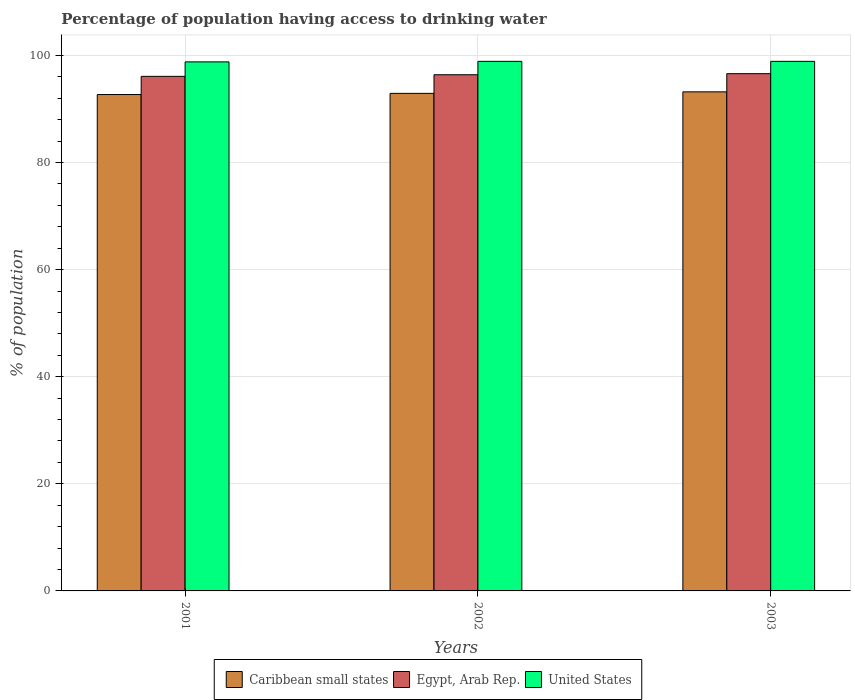How many different coloured bars are there?
Your response must be concise. 3. How many groups of bars are there?
Provide a short and direct response. 3. In how many cases, is the number of bars for a given year not equal to the number of legend labels?
Your answer should be very brief. 0. What is the percentage of population having access to drinking water in Caribbean small states in 2001?
Provide a succinct answer. 92.7. Across all years, what is the maximum percentage of population having access to drinking water in Egypt, Arab Rep.?
Keep it short and to the point. 96.6. Across all years, what is the minimum percentage of population having access to drinking water in Caribbean small states?
Ensure brevity in your answer.  92.7. What is the total percentage of population having access to drinking water in United States in the graph?
Give a very brief answer. 296.6. What is the difference between the percentage of population having access to drinking water in United States in 2001 and that in 2002?
Offer a terse response. -0.1. What is the difference between the percentage of population having access to drinking water in Egypt, Arab Rep. in 2001 and the percentage of population having access to drinking water in Caribbean small states in 2002?
Your answer should be very brief. 3.18. What is the average percentage of population having access to drinking water in United States per year?
Your answer should be very brief. 98.87. In the year 2003, what is the difference between the percentage of population having access to drinking water in Caribbean small states and percentage of population having access to drinking water in United States?
Ensure brevity in your answer.  -5.69. What is the ratio of the percentage of population having access to drinking water in Egypt, Arab Rep. in 2001 to that in 2002?
Keep it short and to the point. 1. Is the percentage of population having access to drinking water in Caribbean small states in 2001 less than that in 2003?
Your answer should be compact. Yes. Is the difference between the percentage of population having access to drinking water in Caribbean small states in 2001 and 2002 greater than the difference between the percentage of population having access to drinking water in United States in 2001 and 2002?
Keep it short and to the point. No. What is the difference between the highest and the second highest percentage of population having access to drinking water in United States?
Provide a short and direct response. 0. What is the difference between the highest and the lowest percentage of population having access to drinking water in United States?
Make the answer very short. 0.1. In how many years, is the percentage of population having access to drinking water in United States greater than the average percentage of population having access to drinking water in United States taken over all years?
Your answer should be compact. 2. Is the sum of the percentage of population having access to drinking water in Egypt, Arab Rep. in 2002 and 2003 greater than the maximum percentage of population having access to drinking water in United States across all years?
Keep it short and to the point. Yes. What does the 1st bar from the left in 2001 represents?
Keep it short and to the point. Caribbean small states. What does the 1st bar from the right in 2002 represents?
Provide a short and direct response. United States. How many bars are there?
Keep it short and to the point. 9. How many years are there in the graph?
Offer a very short reply. 3. Are the values on the major ticks of Y-axis written in scientific E-notation?
Your response must be concise. No. Does the graph contain any zero values?
Offer a terse response. No. Does the graph contain grids?
Your answer should be compact. Yes. Where does the legend appear in the graph?
Provide a short and direct response. Bottom center. How many legend labels are there?
Ensure brevity in your answer.  3. How are the legend labels stacked?
Provide a succinct answer. Horizontal. What is the title of the graph?
Your response must be concise. Percentage of population having access to drinking water. What is the label or title of the X-axis?
Provide a succinct answer. Years. What is the label or title of the Y-axis?
Your response must be concise. % of population. What is the % of population in Caribbean small states in 2001?
Make the answer very short. 92.7. What is the % of population of Egypt, Arab Rep. in 2001?
Provide a short and direct response. 96.1. What is the % of population of United States in 2001?
Offer a very short reply. 98.8. What is the % of population in Caribbean small states in 2002?
Your answer should be compact. 92.92. What is the % of population in Egypt, Arab Rep. in 2002?
Make the answer very short. 96.4. What is the % of population of United States in 2002?
Your answer should be compact. 98.9. What is the % of population of Caribbean small states in 2003?
Your answer should be very brief. 93.21. What is the % of population in Egypt, Arab Rep. in 2003?
Your answer should be compact. 96.6. What is the % of population of United States in 2003?
Keep it short and to the point. 98.9. Across all years, what is the maximum % of population of Caribbean small states?
Offer a terse response. 93.21. Across all years, what is the maximum % of population in Egypt, Arab Rep.?
Provide a succinct answer. 96.6. Across all years, what is the maximum % of population of United States?
Offer a very short reply. 98.9. Across all years, what is the minimum % of population in Caribbean small states?
Offer a very short reply. 92.7. Across all years, what is the minimum % of population in Egypt, Arab Rep.?
Your answer should be compact. 96.1. Across all years, what is the minimum % of population of United States?
Provide a succinct answer. 98.8. What is the total % of population of Caribbean small states in the graph?
Your answer should be compact. 278.83. What is the total % of population of Egypt, Arab Rep. in the graph?
Your response must be concise. 289.1. What is the total % of population in United States in the graph?
Your answer should be compact. 296.6. What is the difference between the % of population of Caribbean small states in 2001 and that in 2002?
Your answer should be compact. -0.22. What is the difference between the % of population of Egypt, Arab Rep. in 2001 and that in 2002?
Keep it short and to the point. -0.3. What is the difference between the % of population in Caribbean small states in 2001 and that in 2003?
Give a very brief answer. -0.5. What is the difference between the % of population in United States in 2001 and that in 2003?
Provide a succinct answer. -0.1. What is the difference between the % of population of Caribbean small states in 2002 and that in 2003?
Offer a terse response. -0.28. What is the difference between the % of population of Egypt, Arab Rep. in 2002 and that in 2003?
Your answer should be compact. -0.2. What is the difference between the % of population of United States in 2002 and that in 2003?
Your response must be concise. 0. What is the difference between the % of population of Caribbean small states in 2001 and the % of population of Egypt, Arab Rep. in 2002?
Keep it short and to the point. -3.7. What is the difference between the % of population of Caribbean small states in 2001 and the % of population of United States in 2002?
Keep it short and to the point. -6.2. What is the difference between the % of population of Caribbean small states in 2001 and the % of population of Egypt, Arab Rep. in 2003?
Your response must be concise. -3.9. What is the difference between the % of population in Caribbean small states in 2001 and the % of population in United States in 2003?
Offer a very short reply. -6.2. What is the difference between the % of population in Egypt, Arab Rep. in 2001 and the % of population in United States in 2003?
Offer a very short reply. -2.8. What is the difference between the % of population in Caribbean small states in 2002 and the % of population in Egypt, Arab Rep. in 2003?
Your answer should be compact. -3.68. What is the difference between the % of population in Caribbean small states in 2002 and the % of population in United States in 2003?
Give a very brief answer. -5.98. What is the difference between the % of population of Egypt, Arab Rep. in 2002 and the % of population of United States in 2003?
Your answer should be compact. -2.5. What is the average % of population in Caribbean small states per year?
Offer a very short reply. 92.94. What is the average % of population of Egypt, Arab Rep. per year?
Your answer should be compact. 96.37. What is the average % of population in United States per year?
Ensure brevity in your answer.  98.87. In the year 2001, what is the difference between the % of population of Caribbean small states and % of population of Egypt, Arab Rep.?
Provide a succinct answer. -3.4. In the year 2001, what is the difference between the % of population in Caribbean small states and % of population in United States?
Offer a terse response. -6.1. In the year 2001, what is the difference between the % of population of Egypt, Arab Rep. and % of population of United States?
Give a very brief answer. -2.7. In the year 2002, what is the difference between the % of population in Caribbean small states and % of population in Egypt, Arab Rep.?
Your answer should be very brief. -3.48. In the year 2002, what is the difference between the % of population of Caribbean small states and % of population of United States?
Your response must be concise. -5.98. In the year 2003, what is the difference between the % of population in Caribbean small states and % of population in Egypt, Arab Rep.?
Make the answer very short. -3.39. In the year 2003, what is the difference between the % of population of Caribbean small states and % of population of United States?
Your response must be concise. -5.69. In the year 2003, what is the difference between the % of population of Egypt, Arab Rep. and % of population of United States?
Provide a short and direct response. -2.3. What is the ratio of the % of population of Egypt, Arab Rep. in 2001 to that in 2002?
Your answer should be compact. 1. What is the ratio of the % of population in United States in 2001 to that in 2002?
Offer a very short reply. 1. What is the difference between the highest and the second highest % of population in Caribbean small states?
Provide a succinct answer. 0.28. What is the difference between the highest and the second highest % of population in Egypt, Arab Rep.?
Your answer should be very brief. 0.2. What is the difference between the highest and the lowest % of population of Caribbean small states?
Keep it short and to the point. 0.5. What is the difference between the highest and the lowest % of population in Egypt, Arab Rep.?
Your answer should be compact. 0.5. What is the difference between the highest and the lowest % of population in United States?
Your answer should be very brief. 0.1. 